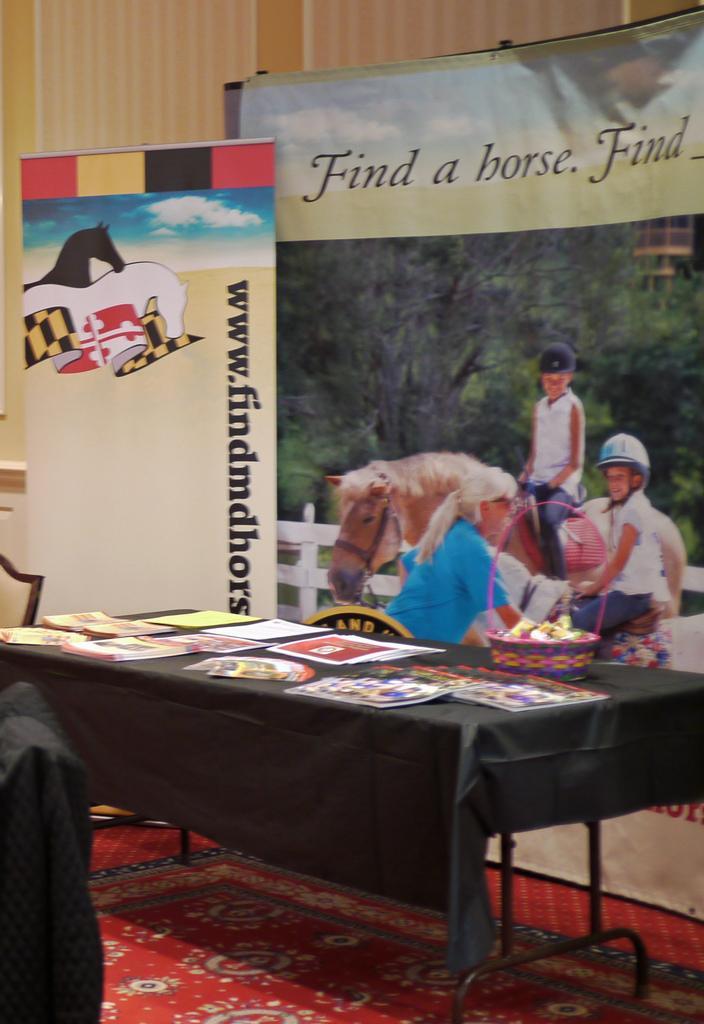Describe this image in one or two sentences. In this image we can see a table and the table is covered with a black colored cloth. On the table we can see some papers and also a basket. In the background we can see the banners and on the banners we can see the text and also the images of humans and also a horse. Wall is also visible. At the bottom there is a red color carpet. 